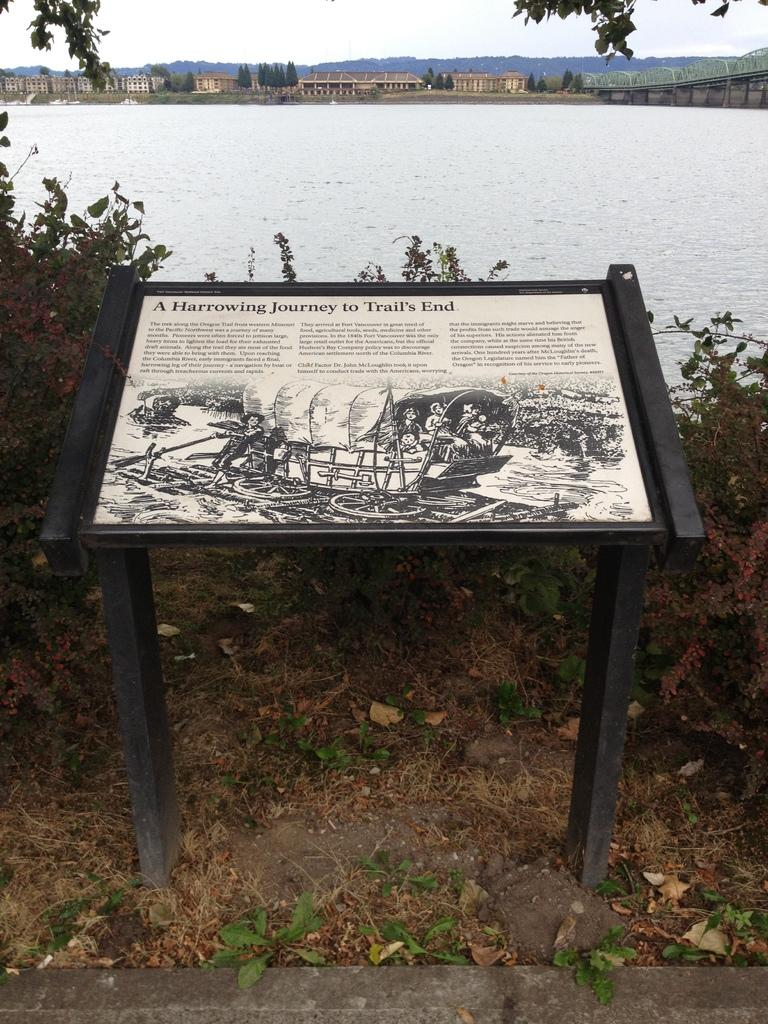What type of furniture is present in the image? There is a table in the image. What is placed on the table? There is a poster on the table. What type of living organisms can be seen in the image? Plants and trees are visible in the image. What is the water visible in the image used for? The water is not explicitly used for anything in the image, but it is visible. What type of structures can be seen in the image? There are houses in the image. What is visible in the background of the image? The sky is visible in the background of the image. How many deer are visible in the image? There are no deer present in the image. What type of grass is growing near the water in the image? There is no grass visible in the image. 